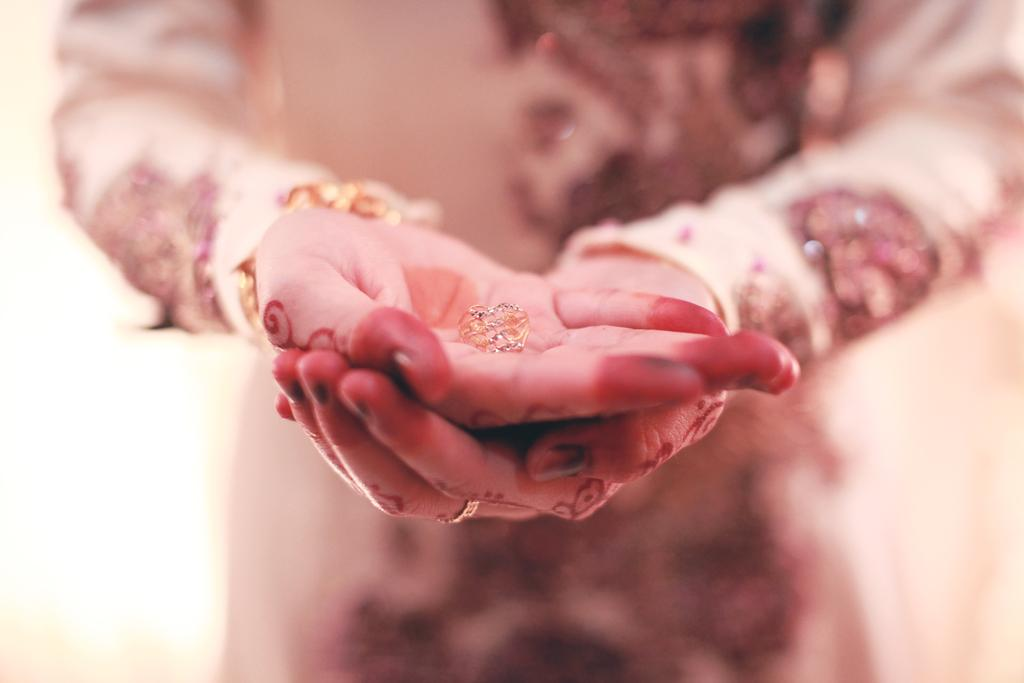What is present in the image? There is a person in the image. What is the person doing in the image? The person is holding an object in her hands. How many frogs can be seen jumping through the hole in the image? There are no frogs or holes present in the image. What type of basketball is the person playing with in the image? There is no basketball present in the image. 